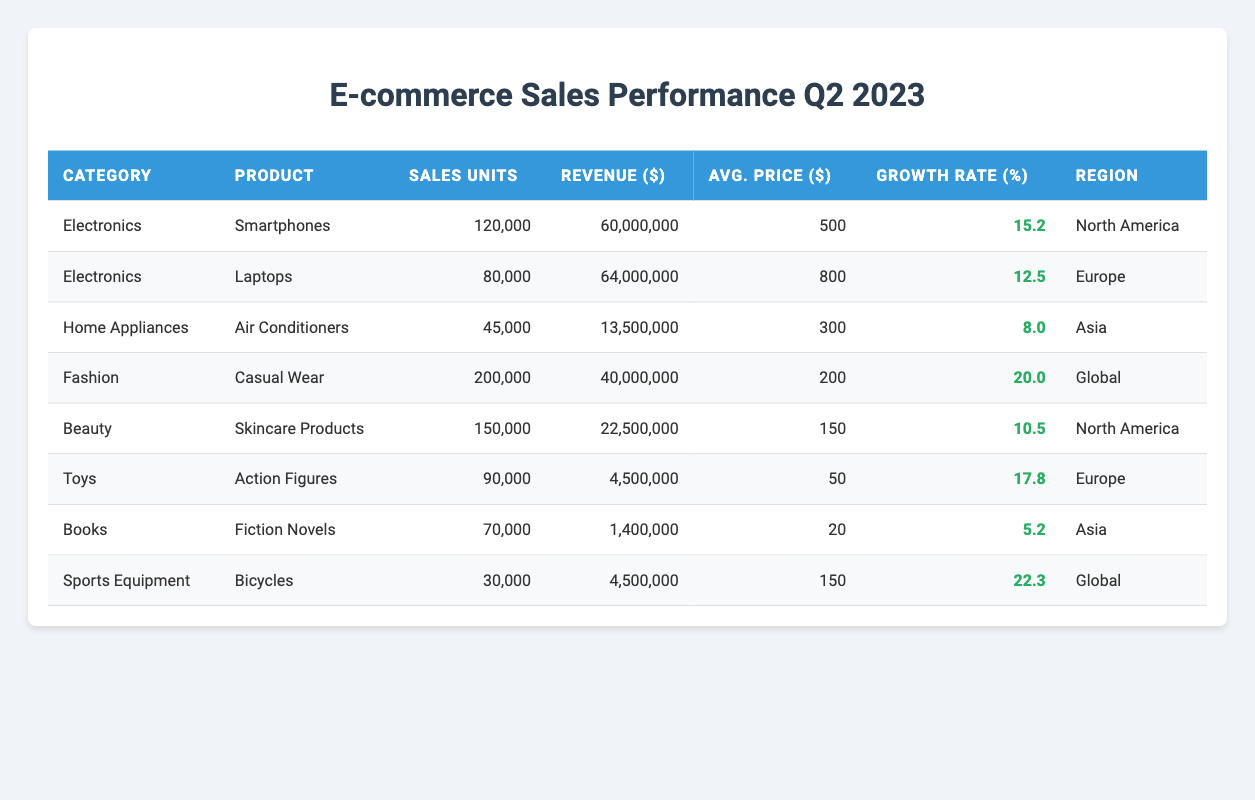What is the total revenue generated from the Electronics category? To find the total revenue from the Electronics category, we add the revenue of all products under Electronics: Smartphone revenue (60,000,000) + Laptop revenue (64,000,000) = 124,000,000.
Answer: 124,000,000 Which product had the highest sales units? By looking at the Sales Units column, the highest value is for Casual Wear with 200,000 units sold.
Answer: Casual Wear What is the average price of all products listed? To calculate the average price, we first sum the average prices of all the products: (500 + 800 + 300 + 200 + 150 + 50 + 20 + 150) = 2,120. There are 8 products, so the average price is 2,120 / 8 = 265.
Answer: 265 Is the growth rate for Air Conditioners higher than that for Fiction Novels? The growth rate for Air Conditioners is 8.0 and for Fiction Novels is 5.2. Since 8.0 is greater than 5.2, the statement is true.
Answer: Yes What is the total sales units for the Home Appliances and Beauty categories combined? We add the sales units for Air Conditioners (45,000) and Skincare Products (150,000): 45,000 + 150,000 = 195,000.
Answer: 195,000 Which region had the highest growth rate for its product? The highest growth rate is for Bicycles in the Sports Equipment category at 22.3%.
Answer: Global How many products had a growth rate above 15 percent? The products with growth rates above 15% are Smartphones (15.2), Casual Wear (20.0), Action Figures (17.8), and Bicycles (22.3). This gives us a total of 4 products.
Answer: 4 What is the revenue contribution of Fashion products compared to the total revenue of all products? The revenue for Casual Wear is 40,000,000, and the total revenue is (60,000,000 + 64,000,000 + 13,500,000 + 40,000,000 + 22,500,000 + 4,500,000 + 1,400,000 + 4,500,000) = 210,900,000. The contribution is (40,000,000 / 210,900,000) * 100 = approximately 18.96%.
Answer: 18.96% If we were to rank the categories by revenue, where would 'Toys' fall? The revenue for Toys is 4,500,000, which is the lowest among all categories: Electronics (124,000,000), Fashion (40,000,000), Beauty (22,500,000), Home Appliances (13,500,000), and Books (1,400,000). Thus, Toys is ranked last.
Answer: Last How many products have an average price less than 200 dollars? The products with an average price less than 200 dollars are Action Figures (50), Skincare Products (150), and Fiction Novels (20), totaling 3 products.
Answer: 3 Did the growth rate for Laptops exceed that of Air Conditioners? The growth rate for Laptops is 12.5% and for Air Conditioners is 8.0%. Since 12.5 is more than 8.0, the statement is true.
Answer: Yes 